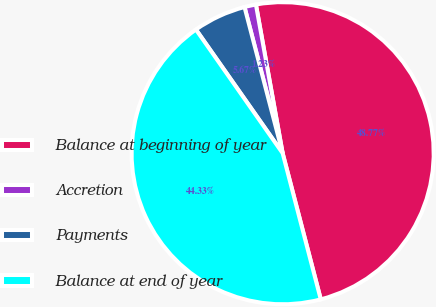<chart> <loc_0><loc_0><loc_500><loc_500><pie_chart><fcel>Balance at beginning of year<fcel>Accretion<fcel>Payments<fcel>Balance at end of year<nl><fcel>48.77%<fcel>1.23%<fcel>5.67%<fcel>44.33%<nl></chart> 